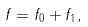Convert formula to latex. <formula><loc_0><loc_0><loc_500><loc_500>f = f _ { 0 } + f _ { 1 } ,</formula> 